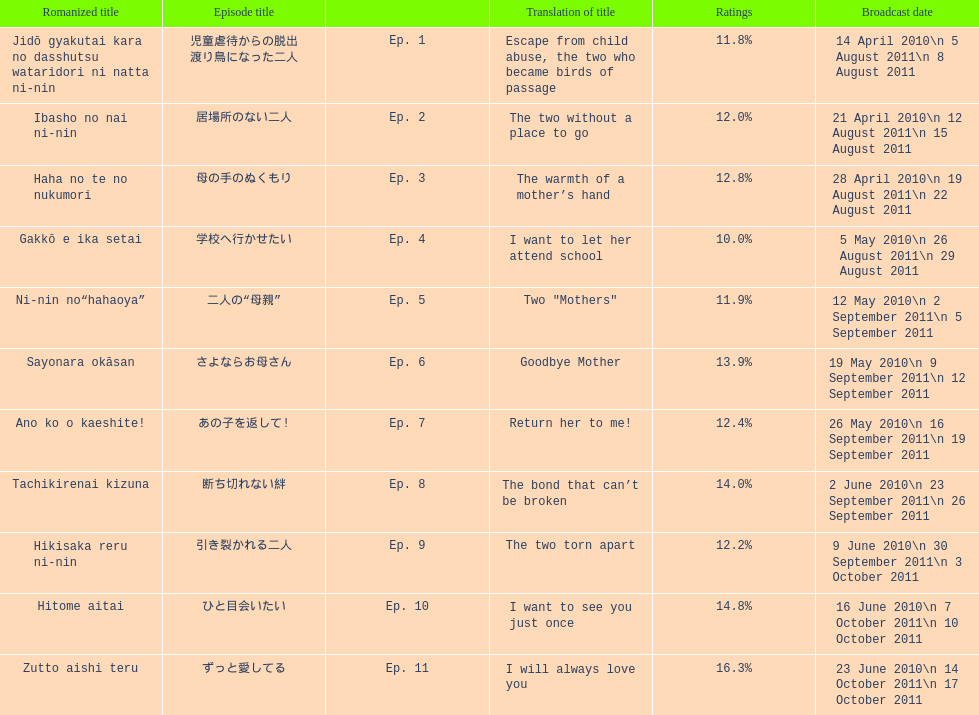What as the percentage total of ratings for episode 8? 14.0%. 